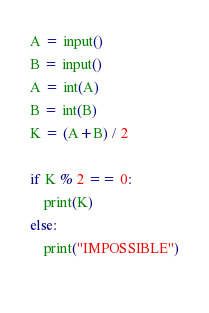<code> <loc_0><loc_0><loc_500><loc_500><_Python_>
A = input()
B = input()
A = int(A)
B = int(B)
K = (A+B) / 2

if K % 2 == 0:
    print(K)
else:
    print("IMPOSSIBLE")
    </code> 